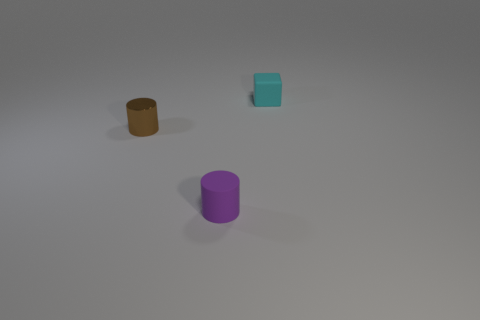The other matte object that is the same shape as the brown object is what size?
Provide a short and direct response. Small. What number of other objects are the same size as the purple rubber thing?
Provide a short and direct response. 2. Is the number of cylinders behind the purple cylinder the same as the number of large red shiny things?
Ensure brevity in your answer.  No. There is a small object that is on the left side of the matte cylinder; does it have the same color as the rubber thing in front of the tiny brown cylinder?
Ensure brevity in your answer.  No. What is the object that is both behind the small purple cylinder and in front of the matte block made of?
Your response must be concise. Metal. The matte cube has what color?
Keep it short and to the point. Cyan. What number of other objects are the same shape as the brown thing?
Offer a very short reply. 1. Are there an equal number of tiny cyan things that are in front of the shiny cylinder and brown shiny objects on the right side of the small cyan block?
Your answer should be very brief. Yes. What is the purple cylinder made of?
Your answer should be very brief. Rubber. What is the small cylinder that is on the right side of the metal cylinder made of?
Offer a very short reply. Rubber. 